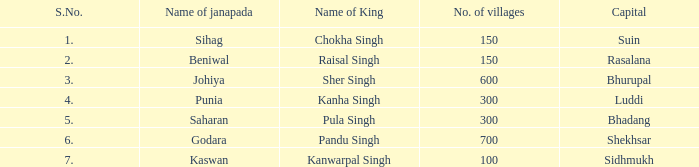What king has an S. number over 1 and a number of villages of 600? Sher Singh. 